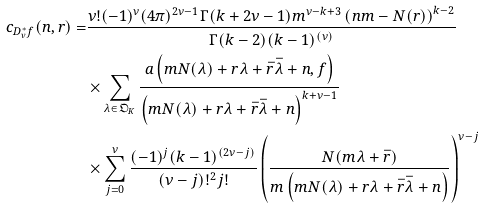Convert formula to latex. <formula><loc_0><loc_0><loc_500><loc_500>c _ { D _ { \nu } ^ { * } f } ( n , r ) = & \frac { \nu ! ( - 1 ) ^ { \nu } ( 4 \pi ) ^ { 2 \nu - 1 } \Gamma ( k + 2 \nu - 1 ) m ^ { \nu - k + 3 } \left ( n m - N ( r ) \right ) ^ { k - 2 } } { \Gamma ( k - 2 ) ( k - 1 ) ^ { \left ( \nu \right ) } } \\ & \times \sum _ { \lambda \in \mathfrak { O } _ { K } } \frac { a \left ( m N ( \lambda ) + r \lambda + \bar { r } \bar { \lambda } + n , f \right ) } { \left ( m N ( \lambda ) + r \lambda + \bar { r } \bar { \lambda } + n \right ) ^ { k + \nu - 1 } } \\ & \times \sum _ { j = 0 } ^ { \nu } \frac { ( - 1 ) ^ { j } ( k - 1 ) ^ { \left ( 2 \nu - j \right ) } } { \left ( \nu - j \right ) ! ^ { 2 } j ! } \left ( \frac { N ( m \lambda + \bar { r } ) } { m \left ( m N ( \lambda ) + r \lambda + \bar { r } \bar { \lambda } + n \right ) } \right ) ^ { \nu - j }</formula> 